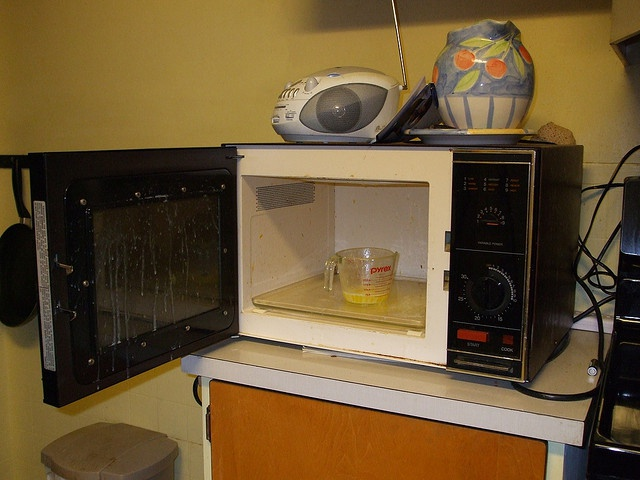Describe the objects in this image and their specific colors. I can see microwave in olive, black, gray, and tan tones, vase in olive, gray, and tan tones, and cup in olive and tan tones in this image. 